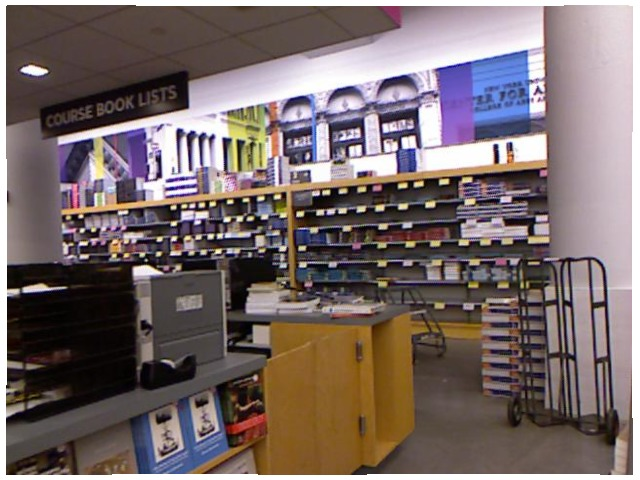<image>
Is the appliance under the counter? Yes. The appliance is positioned underneath the counter, with the counter above it in the vertical space. Is there a tape in front of the counter? No. The tape is not in front of the counter. The spatial positioning shows a different relationship between these objects. 